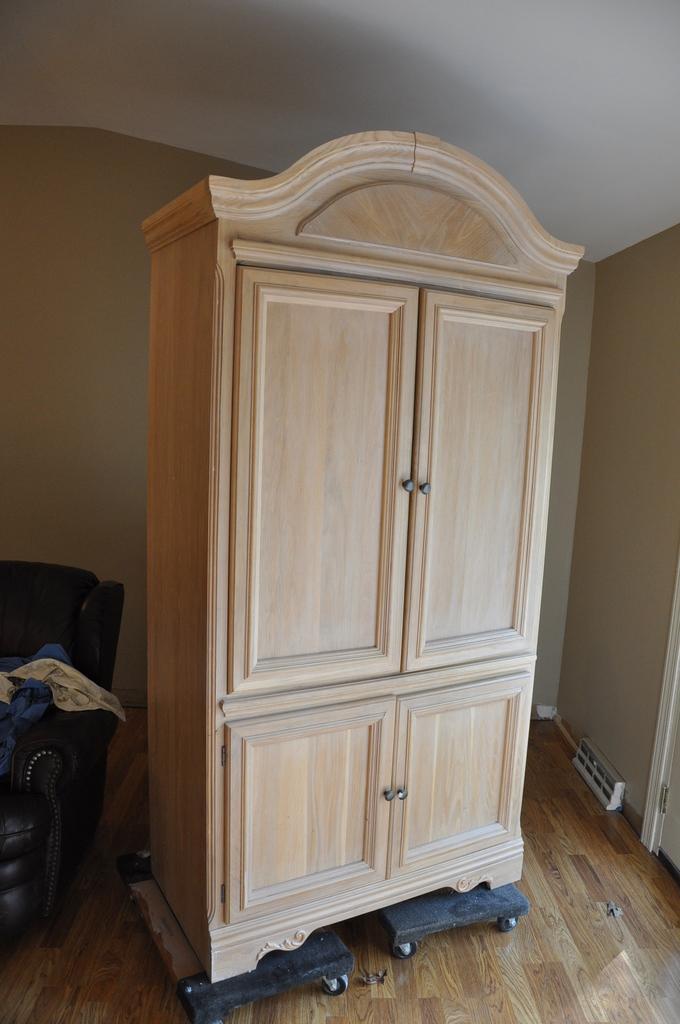Please provide a concise description of this image. This image is taken indoors. In the background there is a wall. At the top of the image there is a roof. In the middle of the image there is a wooden wardrobe on the floor. On the left side of the image there is an object. 